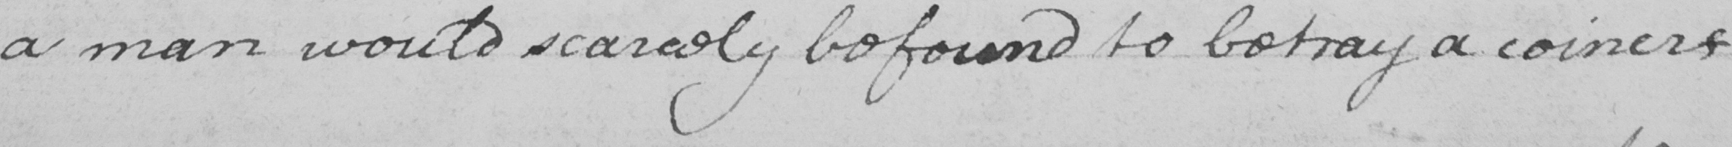Can you read and transcribe this handwriting? a man would scarcely be found to betray a coiner 